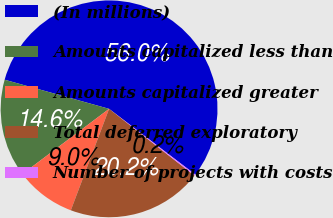Convert chart to OTSL. <chart><loc_0><loc_0><loc_500><loc_500><pie_chart><fcel>(In millions)<fcel>Amounts capitalized less than<fcel>Amounts capitalized greater<fcel>Total deferred exploratory<fcel>Number of projects with costs<nl><fcel>56.04%<fcel>14.59%<fcel>9.0%<fcel>20.17%<fcel>0.2%<nl></chart> 